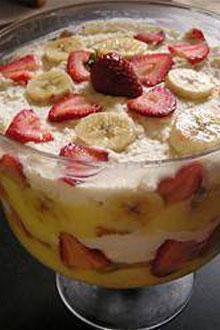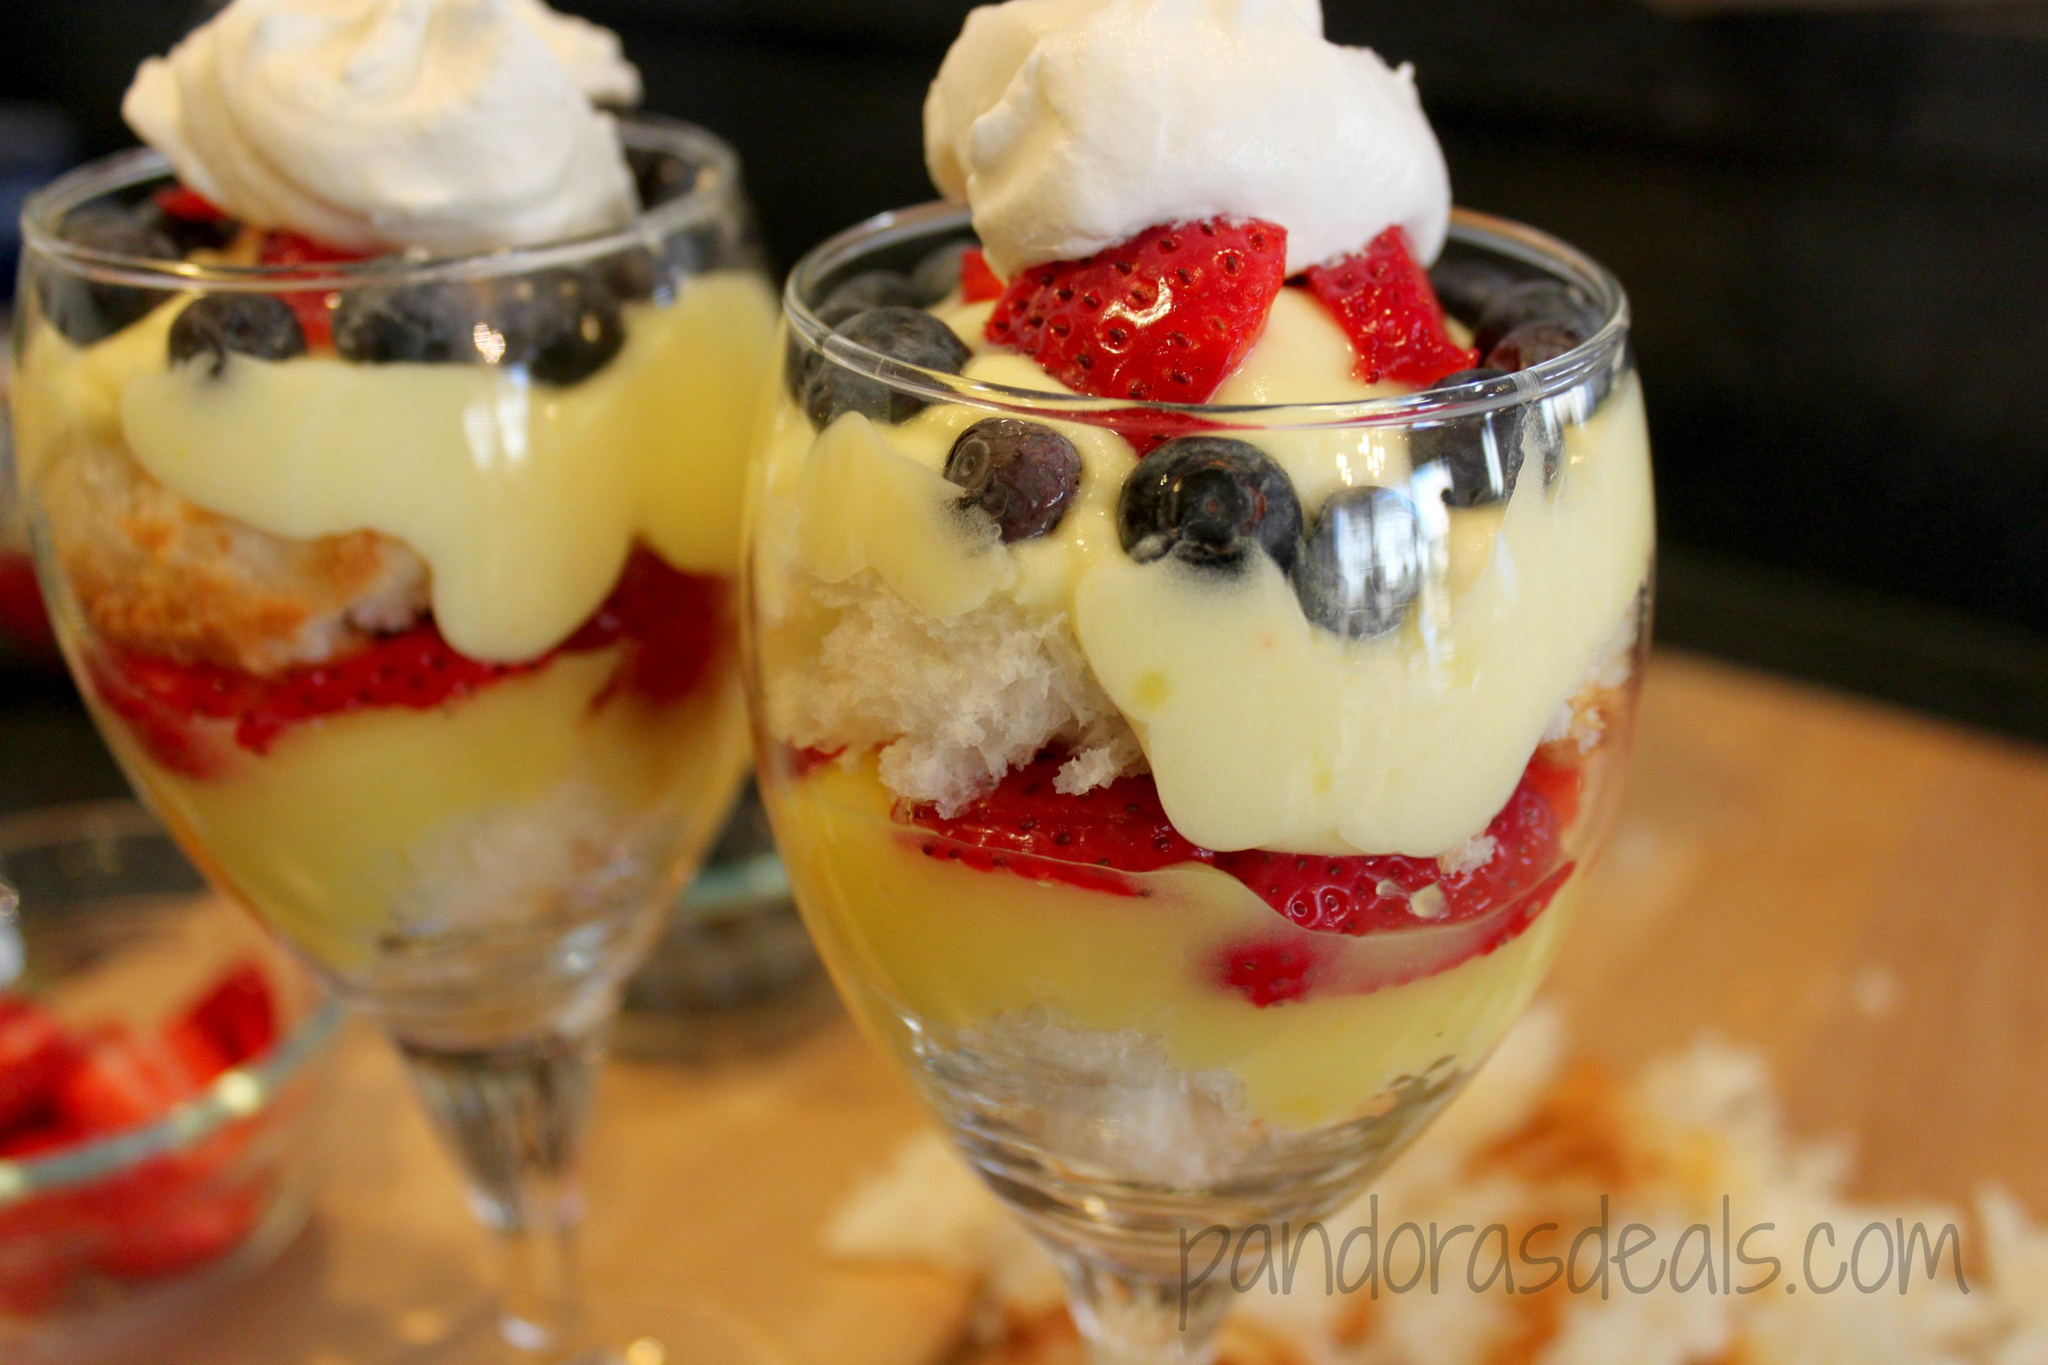The first image is the image on the left, the second image is the image on the right. Analyze the images presented: Is the assertion "One of the images contains exactly two dessert filled containers." valid? Answer yes or no. Yes. 